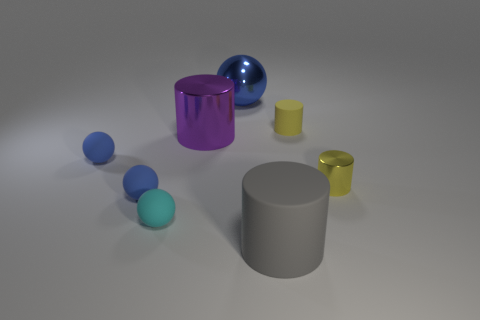What number of things are either yellow shiny objects or large yellow matte cylinders? In the image, we can observe various objects with different colors and finishes. Among them, there appears to be no yellow shiny objects and only one large matte cylinder, but it is not yellow. So the correct answer to the original question is zero, as there are no objects that fit the criteria of being either a yellow shiny object or a large yellow matte cylinder. 